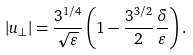<formula> <loc_0><loc_0><loc_500><loc_500>| u _ { \perp } | = \frac { 3 ^ { 1 / 4 } } { \sqrt { \varepsilon } } \left ( 1 - \frac { 3 ^ { 3 / 2 } } { 2 } \frac { \delta } { \varepsilon } \right ) .</formula> 